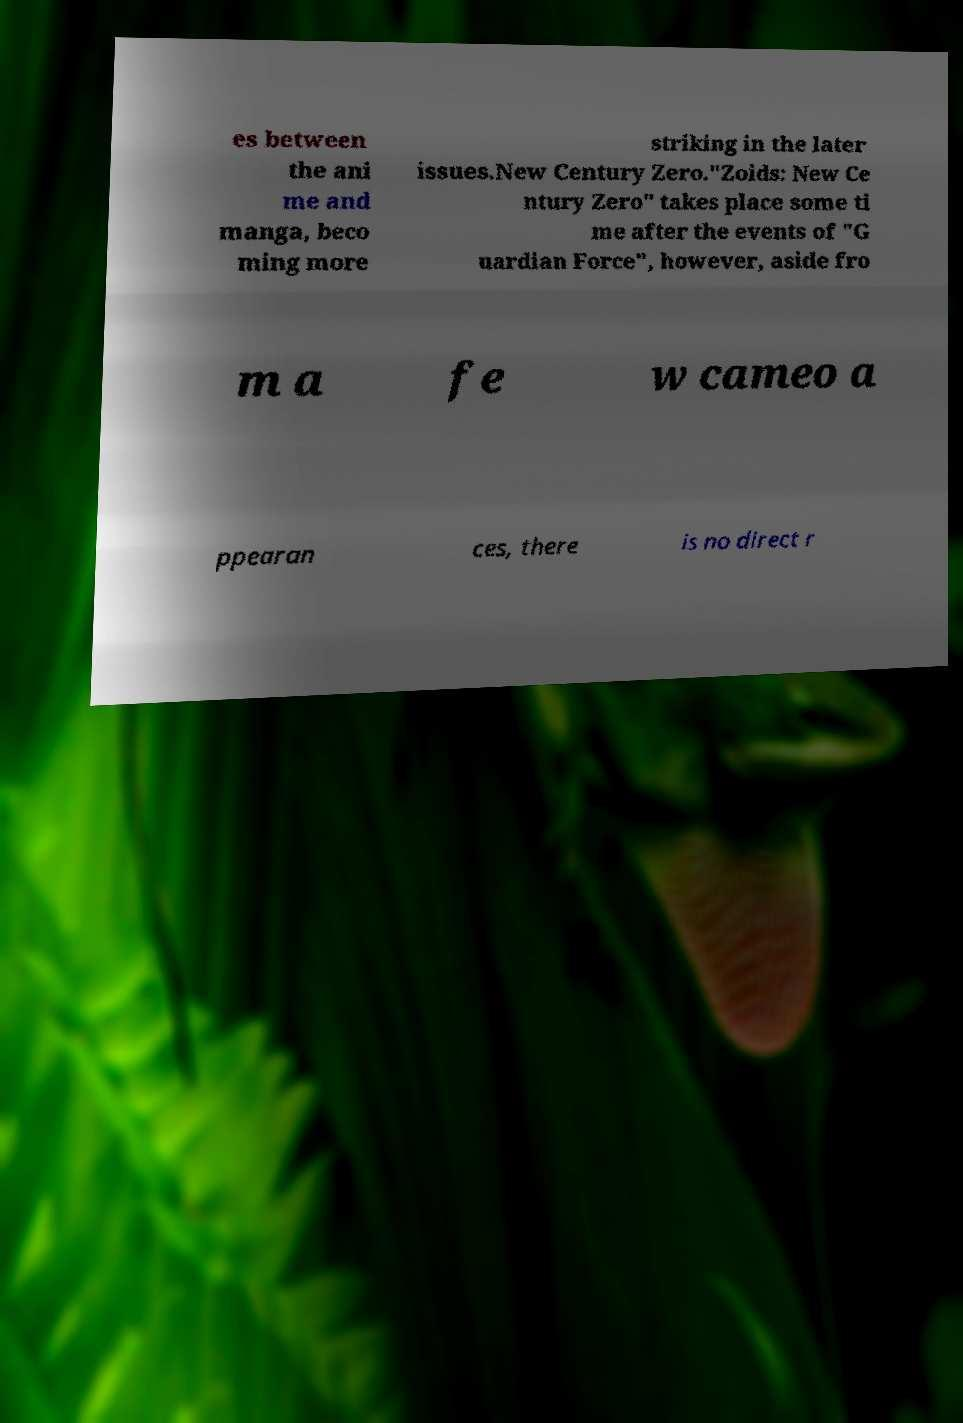Please identify and transcribe the text found in this image. es between the ani me and manga, beco ming more striking in the later issues.New Century Zero."Zoids: New Ce ntury Zero" takes place some ti me after the events of "G uardian Force", however, aside fro m a fe w cameo a ppearan ces, there is no direct r 